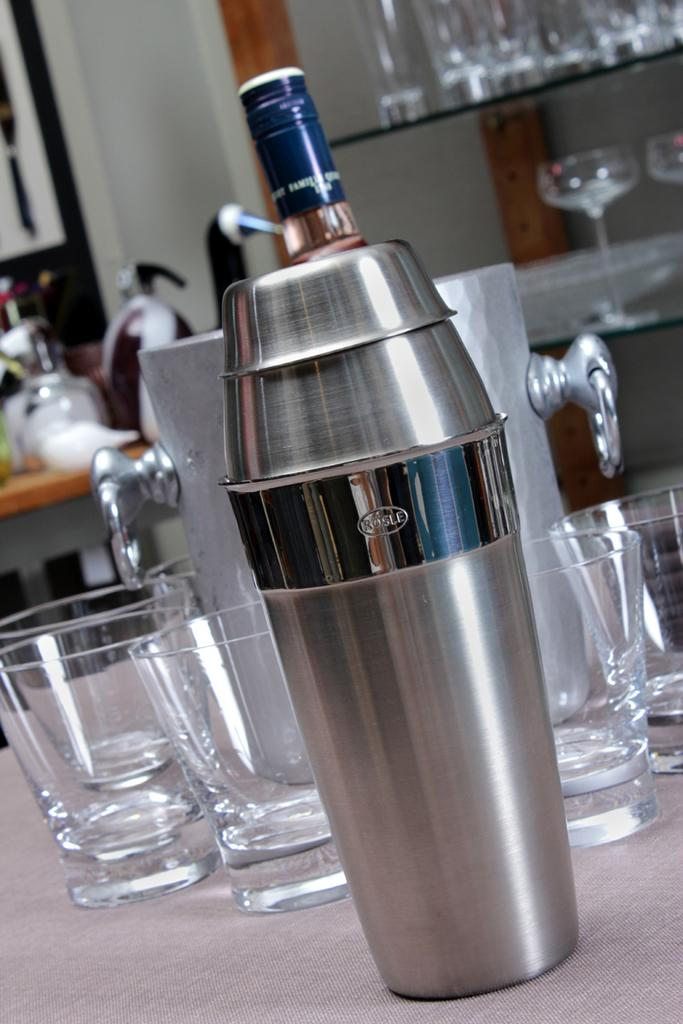Provide a one-sentence caption for the provided image. a Rosle cocktail mixer is in front of a wine cooler and glasses. 